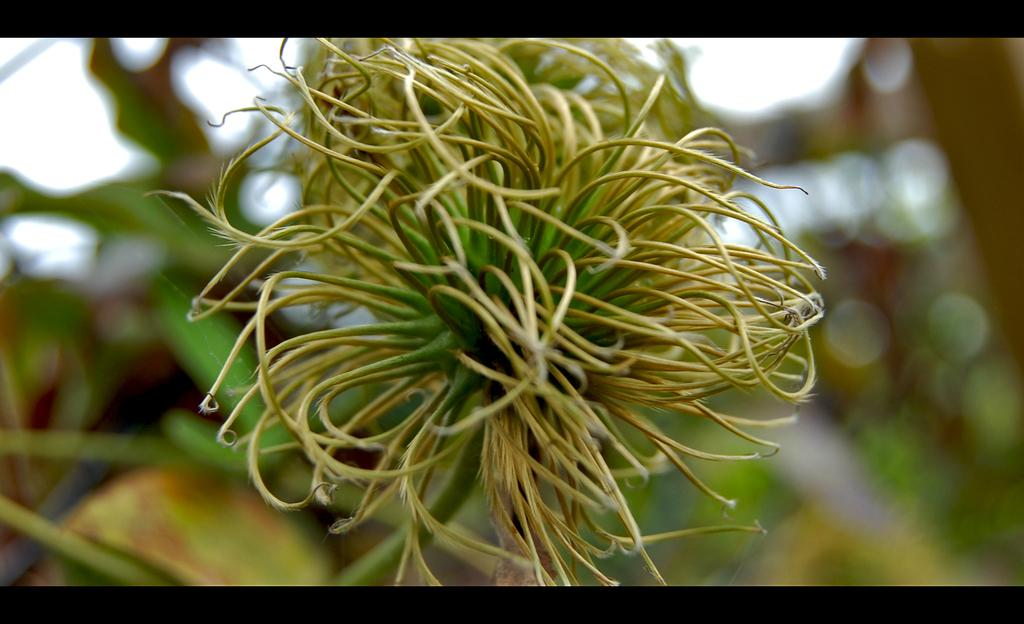What is present in the image? There is a plant in the image. Can you describe the background of the image? The background of the image is blurry. What type of learning can be observed in the image? There is no learning activity present in the image; it features a plant and a blurry background. 